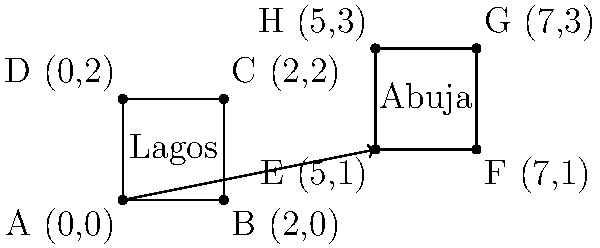Given the coordinates of two tech hubs in Nigeria, Lagos (represented by square ABCD) and Abuja (represented by square EFGH), determine the translation vector that would move Lagos to Abuja's position. How would this translation affect the distribution of venture capital investments across the country? To solve this problem, we need to follow these steps:

1. Identify the coordinates of corresponding points in both squares:
   Lagos: A(0,0), B(2,0), C(2,2), D(0,2)
   Abuja: E(5,1), F(7,1), G(7,3), H(5,3)

2. Calculate the translation vector by subtracting the coordinates of any corresponding points:
   Vector = E - A = (5,1) - (0,0) = (5,1)

3. Verify the translation vector using other corresponding points:
   F - B = (7,1) - (2,0) = (5,1)
   G - C = (7,3) - (2,2) = (5,1)
   H - D = (5,3) - (0,2) = (5,1)

4. Express the translation as a vector: $\vec{v} = \langle 5, 1 \rangle$

5. Interpret the effect on venture capital distribution:
   - The translation moves the tech hub 5 units to the right and 1 unit up.
   - This creates a more balanced distribution of tech hubs across Nigeria.
   - A wider geographical spread of tech hubs can attract diverse investments.
   - It may lead to more equitable development and reduce concentration risk.
   - The translation could encourage investors to explore opportunities beyond Lagos.

The translation vector $\langle 5, 1 \rangle$ represents a strategic relocation that could potentially attract more diverse venture capital investments across Nigeria.
Answer: Translation vector: $\langle 5, 1 \rangle$ 